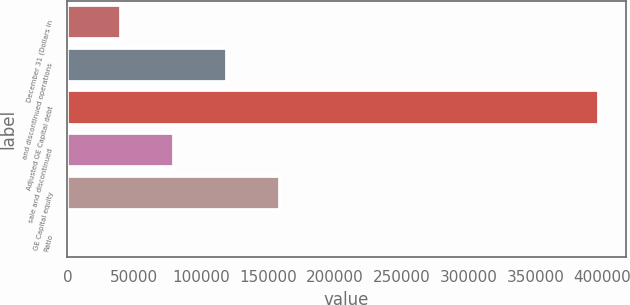<chart> <loc_0><loc_0><loc_500><loc_500><bar_chart><fcel>December 31 (Dollars in<fcel>and discontinued operations<fcel>Adjusted GE Capital debt<fcel>sale and discontinued<fcel>GE Capital equity<fcel>Ratio<nl><fcel>39747.9<fcel>119235<fcel>397442<fcel>79491.7<fcel>158979<fcel>4.09<nl></chart> 